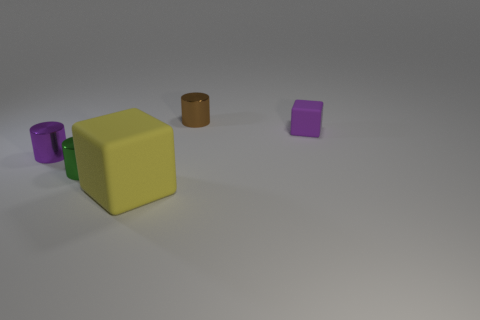Add 1 green rubber things. How many objects exist? 6 Subtract all cubes. How many objects are left? 3 Subtract all cylinders. Subtract all tiny matte objects. How many objects are left? 1 Add 5 purple objects. How many purple objects are left? 7 Add 5 green things. How many green things exist? 6 Subtract 0 gray cylinders. How many objects are left? 5 